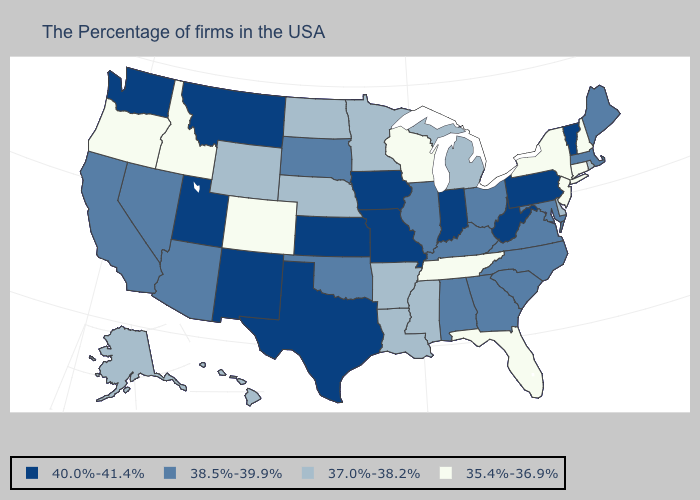Name the states that have a value in the range 35.4%-36.9%?
Give a very brief answer. New Hampshire, Connecticut, New York, New Jersey, Florida, Tennessee, Wisconsin, Colorado, Idaho, Oregon. What is the highest value in the USA?
Answer briefly. 40.0%-41.4%. Which states have the lowest value in the USA?
Quick response, please. New Hampshire, Connecticut, New York, New Jersey, Florida, Tennessee, Wisconsin, Colorado, Idaho, Oregon. Does Iowa have the same value as Missouri?
Write a very short answer. Yes. What is the value of Washington?
Be succinct. 40.0%-41.4%. What is the value of Idaho?
Write a very short answer. 35.4%-36.9%. Name the states that have a value in the range 38.5%-39.9%?
Keep it brief. Maine, Massachusetts, Maryland, Virginia, North Carolina, South Carolina, Ohio, Georgia, Kentucky, Alabama, Illinois, Oklahoma, South Dakota, Arizona, Nevada, California. Does the first symbol in the legend represent the smallest category?
Answer briefly. No. Name the states that have a value in the range 35.4%-36.9%?
Short answer required. New Hampshire, Connecticut, New York, New Jersey, Florida, Tennessee, Wisconsin, Colorado, Idaho, Oregon. Name the states that have a value in the range 38.5%-39.9%?
Answer briefly. Maine, Massachusetts, Maryland, Virginia, North Carolina, South Carolina, Ohio, Georgia, Kentucky, Alabama, Illinois, Oklahoma, South Dakota, Arizona, Nevada, California. Name the states that have a value in the range 38.5%-39.9%?
Concise answer only. Maine, Massachusetts, Maryland, Virginia, North Carolina, South Carolina, Ohio, Georgia, Kentucky, Alabama, Illinois, Oklahoma, South Dakota, Arizona, Nevada, California. Among the states that border Alabama , does Tennessee have the lowest value?
Give a very brief answer. Yes. What is the value of Massachusetts?
Be succinct. 38.5%-39.9%. What is the value of New Jersey?
Concise answer only. 35.4%-36.9%. 